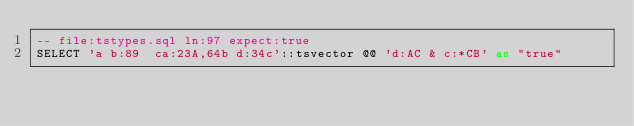<code> <loc_0><loc_0><loc_500><loc_500><_SQL_>-- file:tstypes.sql ln:97 expect:true
SELECT 'a b:89  ca:23A,64b d:34c'::tsvector @@ 'd:AC & c:*CB' as "true"
</code> 